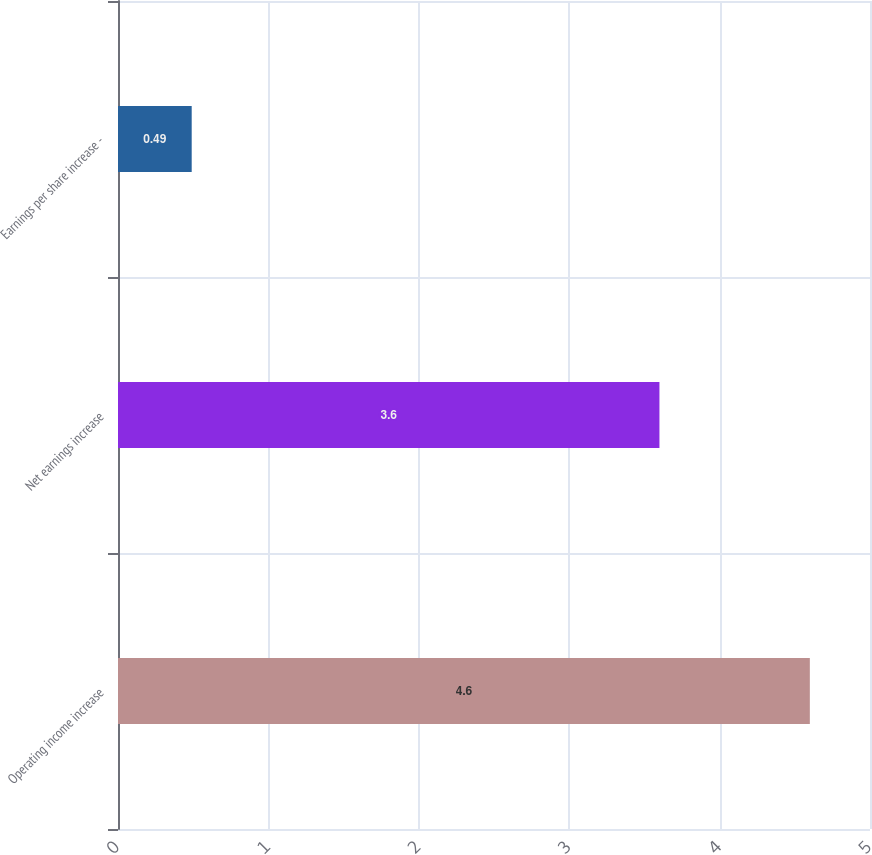<chart> <loc_0><loc_0><loc_500><loc_500><bar_chart><fcel>Operating income increase<fcel>Net earnings increase<fcel>Earnings per share increase -<nl><fcel>4.6<fcel>3.6<fcel>0.49<nl></chart> 